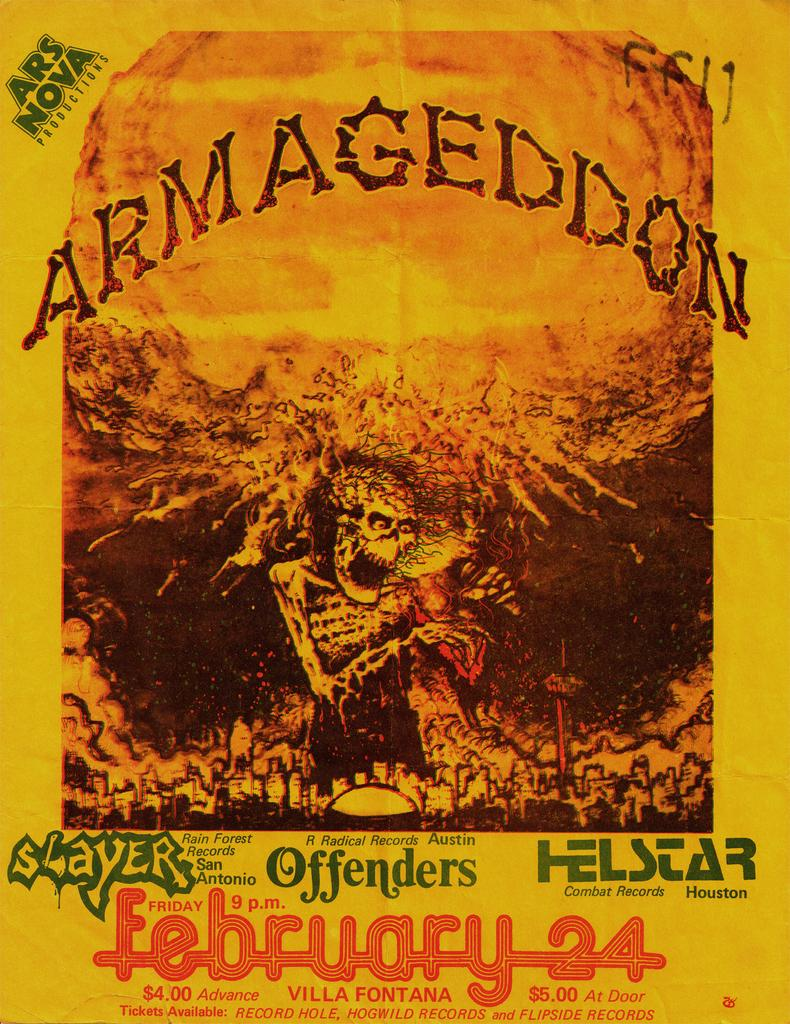Provide a one-sentence caption for the provided image. a poster with the words Armageddon and a skeleton on the front. 